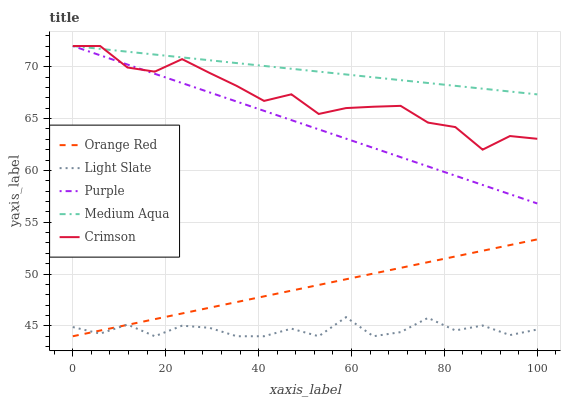Does Light Slate have the minimum area under the curve?
Answer yes or no. Yes. Does Medium Aqua have the maximum area under the curve?
Answer yes or no. Yes. Does Purple have the minimum area under the curve?
Answer yes or no. No. Does Purple have the maximum area under the curve?
Answer yes or no. No. Is Medium Aqua the smoothest?
Answer yes or no. Yes. Is Light Slate the roughest?
Answer yes or no. Yes. Is Purple the smoothest?
Answer yes or no. No. Is Purple the roughest?
Answer yes or no. No. Does Light Slate have the lowest value?
Answer yes or no. Yes. Does Purple have the lowest value?
Answer yes or no. No. Does Crimson have the highest value?
Answer yes or no. Yes. Does Orange Red have the highest value?
Answer yes or no. No. Is Light Slate less than Crimson?
Answer yes or no. Yes. Is Purple greater than Orange Red?
Answer yes or no. Yes. Does Crimson intersect Purple?
Answer yes or no. Yes. Is Crimson less than Purple?
Answer yes or no. No. Is Crimson greater than Purple?
Answer yes or no. No. Does Light Slate intersect Crimson?
Answer yes or no. No. 